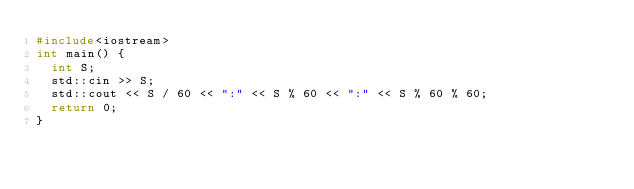<code> <loc_0><loc_0><loc_500><loc_500><_C++_>#include<iostream>
int main() {
	int S;
	std::cin >> S;
	std::cout << S / 60 << ":" << S % 60 << ":" << S % 60 % 60;
	return 0;
}
</code> 